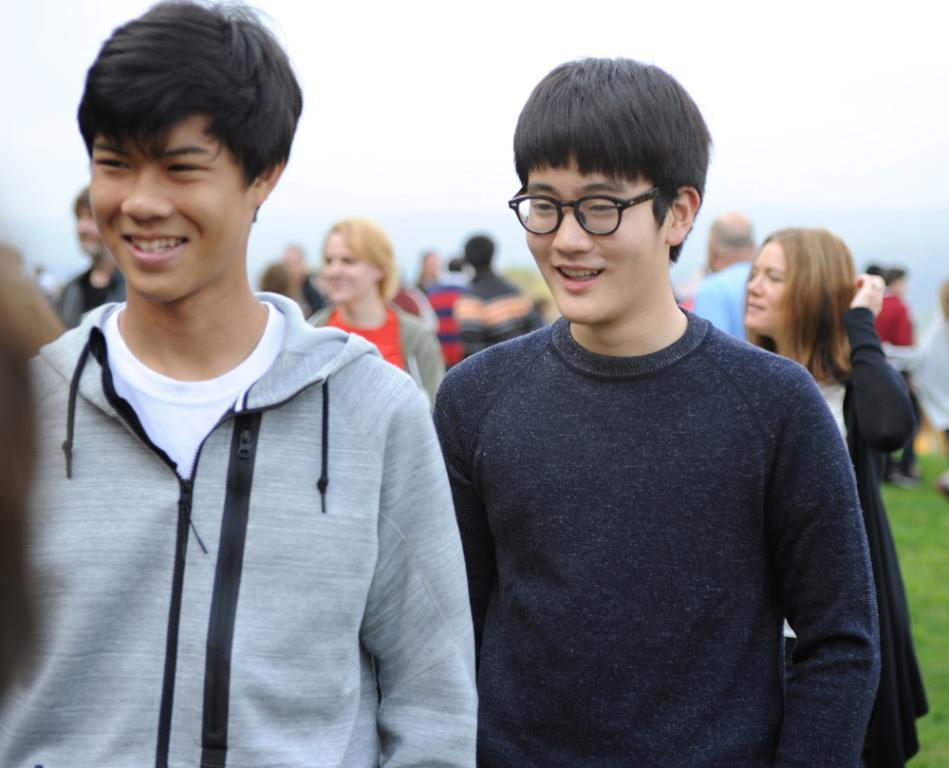Who or what is present in the image? There are people in the image. What type of surface can be seen beneath the people? There is grass in the image. What can be seen in the distance behind the people? The sky is visible in the background of the image. What type of prose is being recited by the people in the image? There is no indication in the image that the people are reciting any prose. 